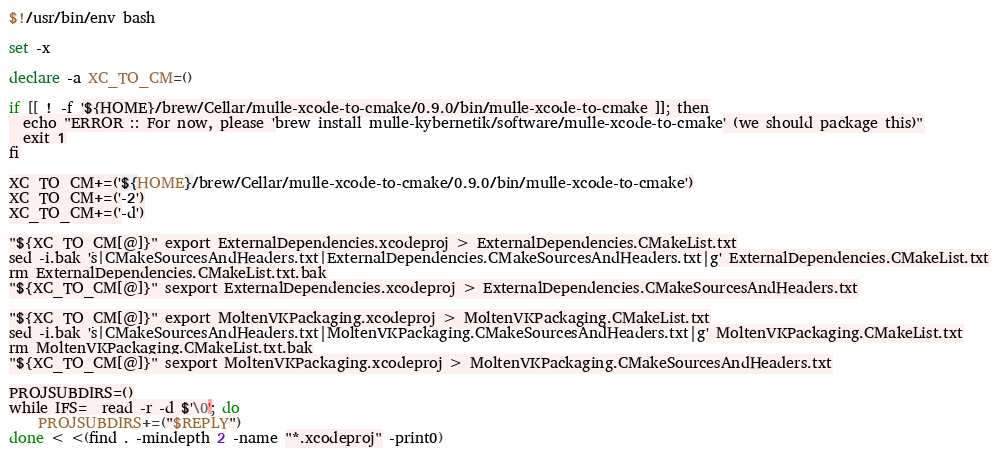Convert code to text. <code><loc_0><loc_0><loc_500><loc_500><_Bash_>$!/usr/bin/env bash

set -x

declare -a XC_TO_CM=()

if [[ ! -f '${HOME}/brew/Cellar/mulle-xcode-to-cmake/0.9.0/bin/mulle-xcode-to-cmake ]]; then
  echo "ERROR :: For now, please 'brew install mulle-kybernetik/software/mulle-xcode-to-cmake' (we should package this)"
  exit 1
fi

XC_TO_CM+=('${HOME}/brew/Cellar/mulle-xcode-to-cmake/0.9.0/bin/mulle-xcode-to-cmake')
XC_TO_CM+=('-2')
XC_TO_CM+=('-d')

"${XC_TO_CM[@]}" export ExternalDependencies.xcodeproj > ExternalDependencies.CMakeList.txt
sed -i.bak 's|CMakeSourcesAndHeaders.txt|ExternalDependencies.CMakeSourcesAndHeaders.txt|g' ExternalDependencies.CMakeList.txt
rm ExternalDependencies.CMakeList.txt.bak
"${XC_TO_CM[@]}" sexport ExternalDependencies.xcodeproj > ExternalDependencies.CMakeSourcesAndHeaders.txt

"${XC_TO_CM[@]}" export MoltenVKPackaging.xcodeproj > MoltenVKPackaging.CMakeList.txt
sed -i.bak 's|CMakeSourcesAndHeaders.txt|MoltenVKPackaging.CMakeSourcesAndHeaders.txt|g' MoltenVKPackaging.CMakeList.txt
rm MoltenVKPackaging.CMakeList.txt.bak
"${XC_TO_CM[@]}" sexport MoltenVKPackaging.xcodeproj > MoltenVKPackaging.CMakeSourcesAndHeaders.txt

PROJSUBDIRS=()
while IFS=  read -r -d $'\0'; do
    PROJSUBDIRS+=("$REPLY")
done < <(find . -mindepth 2 -name "*.xcodeproj" -print0)
</code> 